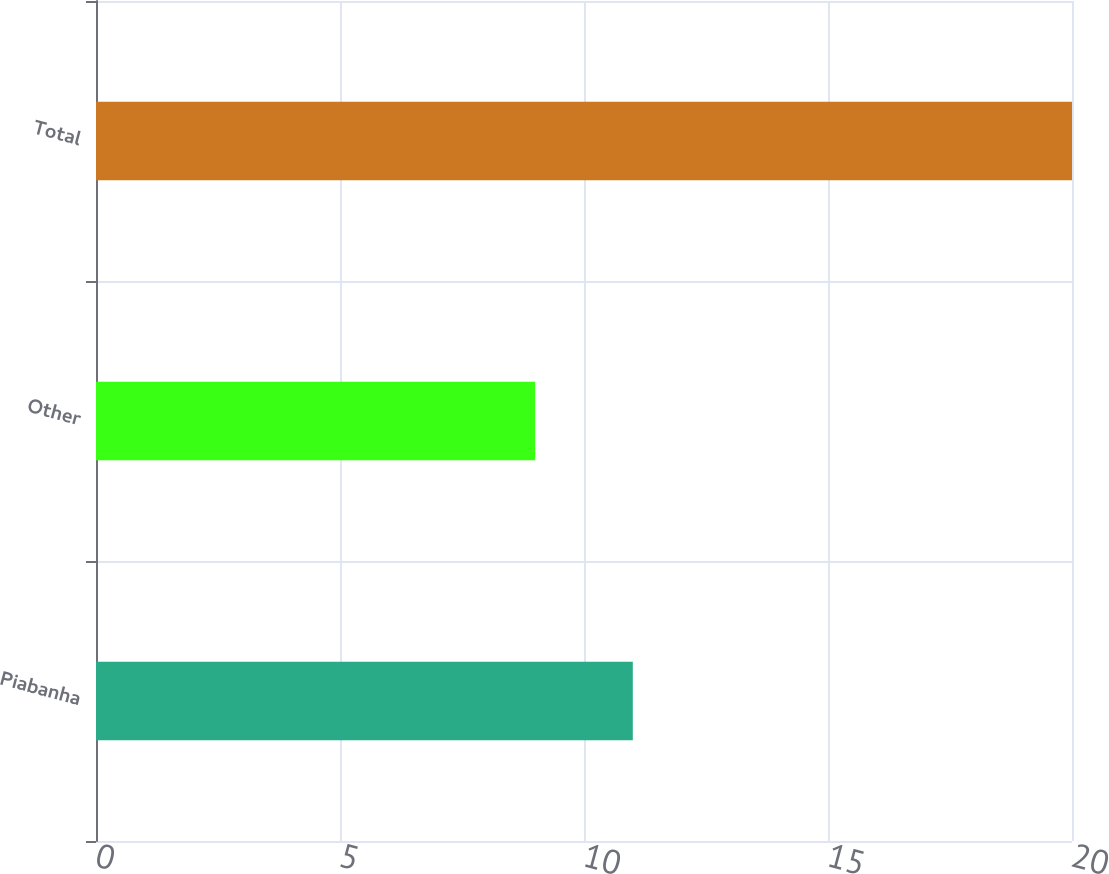Convert chart to OTSL. <chart><loc_0><loc_0><loc_500><loc_500><bar_chart><fcel>Piabanha<fcel>Other<fcel>Total<nl><fcel>11<fcel>9<fcel>20<nl></chart> 